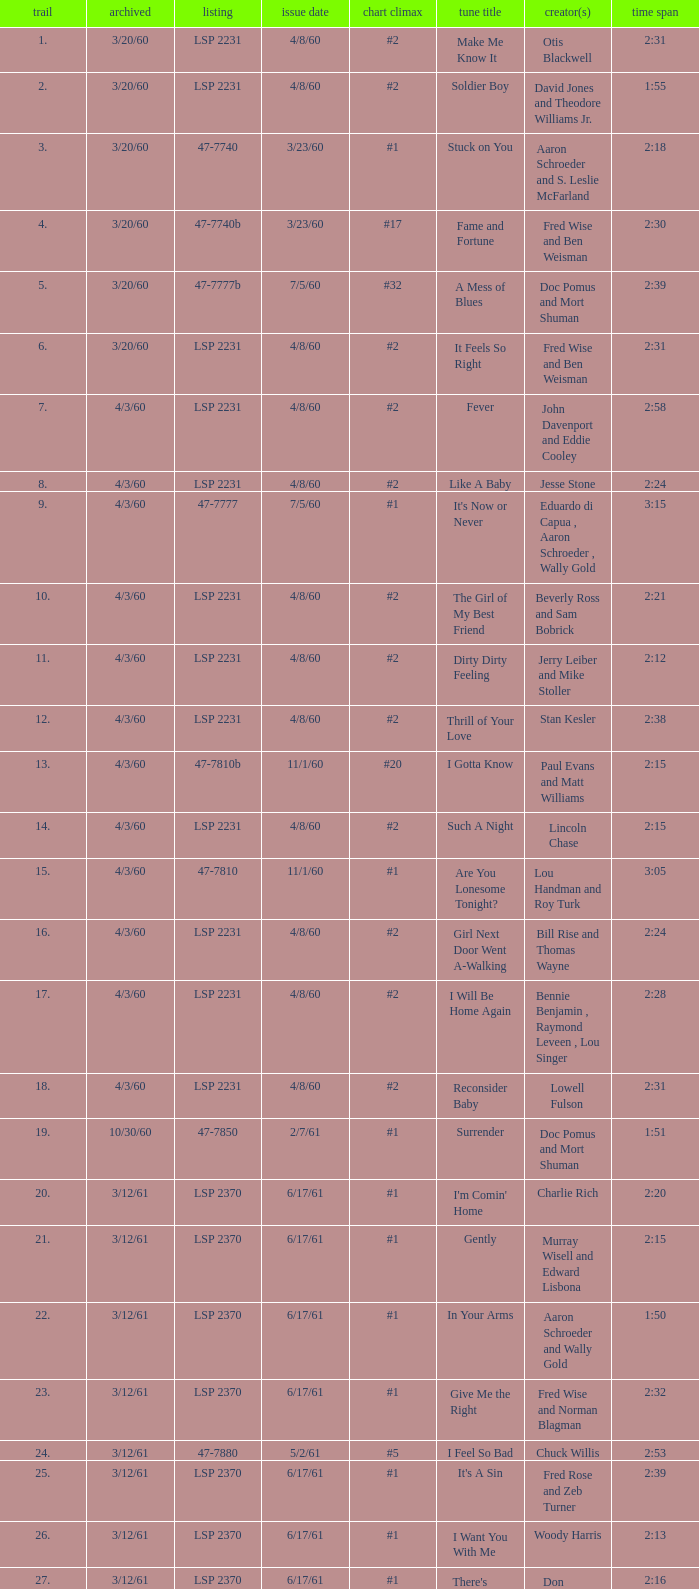On songs with track numbers smaller than number 17 and catalogues of LSP 2231, who are the writer(s)? Otis Blackwell, David Jones and Theodore Williams Jr., Fred Wise and Ben Weisman, John Davenport and Eddie Cooley, Jesse Stone, Beverly Ross and Sam Bobrick, Jerry Leiber and Mike Stoller, Stan Kesler, Lincoln Chase, Bill Rise and Thomas Wayne. 